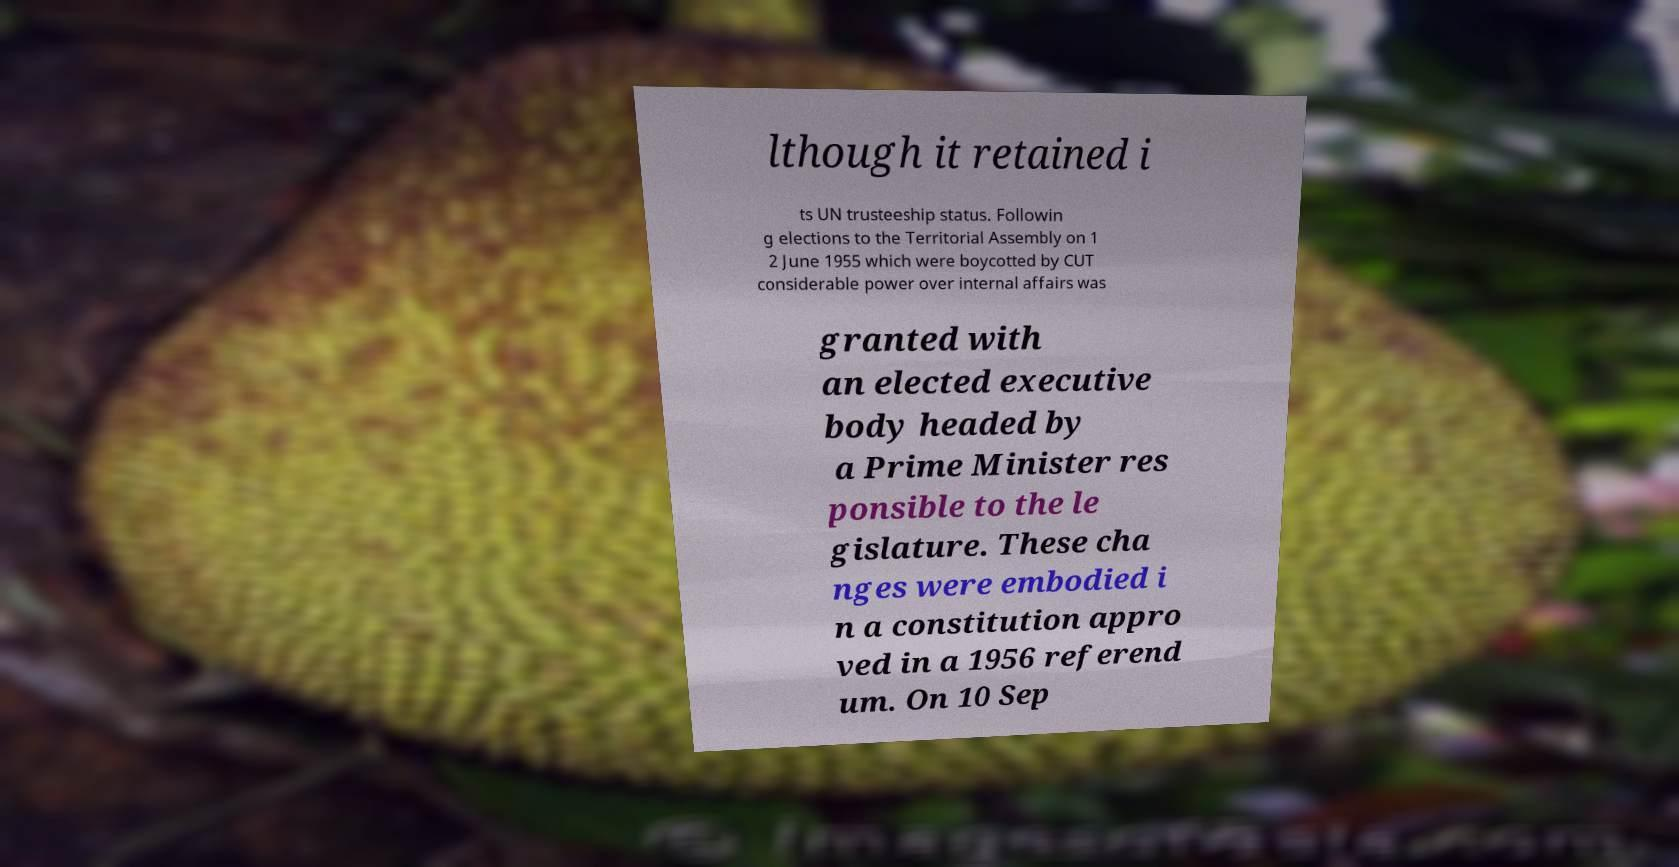For documentation purposes, I need the text within this image transcribed. Could you provide that? lthough it retained i ts UN trusteeship status. Followin g elections to the Territorial Assembly on 1 2 June 1955 which were boycotted by CUT considerable power over internal affairs was granted with an elected executive body headed by a Prime Minister res ponsible to the le gislature. These cha nges were embodied i n a constitution appro ved in a 1956 referend um. On 10 Sep 